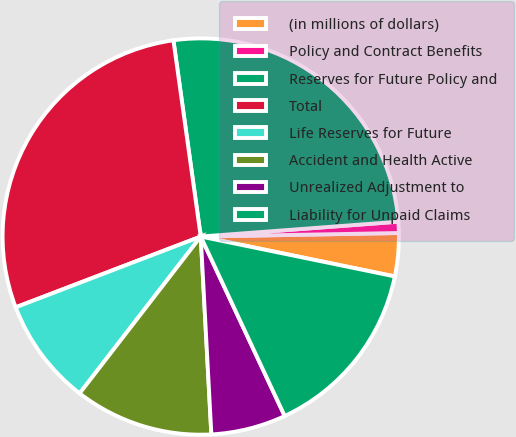Convert chart. <chart><loc_0><loc_0><loc_500><loc_500><pie_chart><fcel>(in millions of dollars)<fcel>Policy and Contract Benefits<fcel>Reserves for Future Policy and<fcel>Total<fcel>Life Reserves for Future<fcel>Accident and Health Active<fcel>Unrealized Adjustment to<fcel>Liability for Unpaid Claims<nl><fcel>3.51%<fcel>0.91%<fcel>26.01%<fcel>28.61%<fcel>8.72%<fcel>11.32%<fcel>6.11%<fcel>14.81%<nl></chart> 